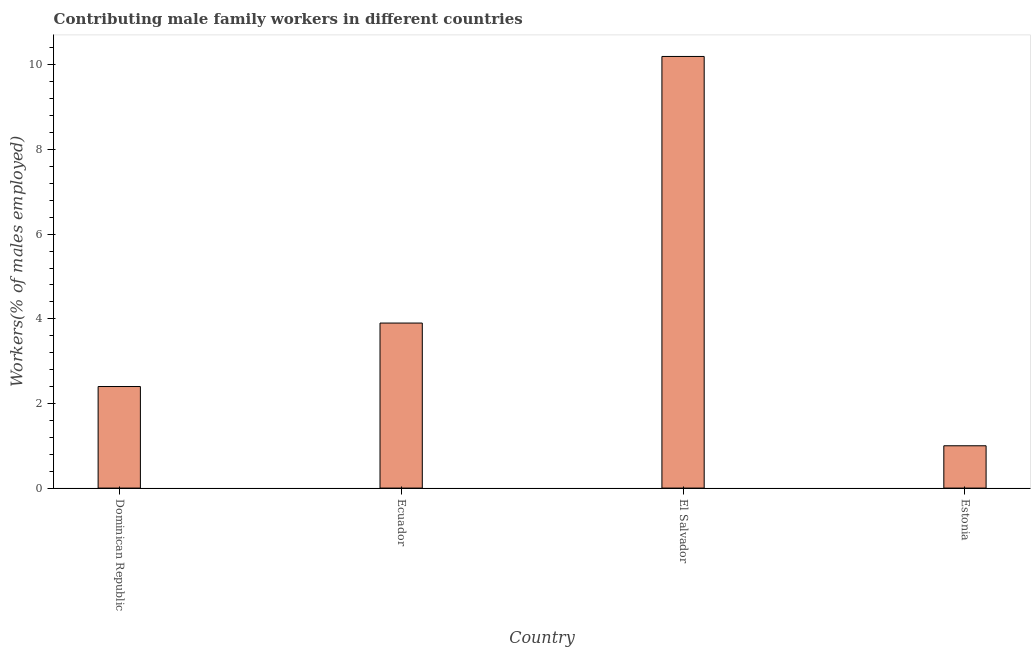What is the title of the graph?
Make the answer very short. Contributing male family workers in different countries. What is the label or title of the X-axis?
Offer a terse response. Country. What is the label or title of the Y-axis?
Give a very brief answer. Workers(% of males employed). What is the contributing male family workers in Dominican Republic?
Offer a terse response. 2.4. Across all countries, what is the maximum contributing male family workers?
Your response must be concise. 10.2. Across all countries, what is the minimum contributing male family workers?
Offer a terse response. 1. In which country was the contributing male family workers maximum?
Your answer should be compact. El Salvador. In which country was the contributing male family workers minimum?
Offer a very short reply. Estonia. What is the sum of the contributing male family workers?
Offer a very short reply. 17.5. What is the difference between the contributing male family workers in Ecuador and El Salvador?
Provide a short and direct response. -6.3. What is the average contributing male family workers per country?
Ensure brevity in your answer.  4.38. What is the median contributing male family workers?
Ensure brevity in your answer.  3.15. What is the ratio of the contributing male family workers in Dominican Republic to that in Estonia?
Ensure brevity in your answer.  2.4. Is the contributing male family workers in Ecuador less than that in El Salvador?
Provide a short and direct response. Yes. Is the difference between the contributing male family workers in El Salvador and Estonia greater than the difference between any two countries?
Make the answer very short. Yes. What is the difference between two consecutive major ticks on the Y-axis?
Ensure brevity in your answer.  2. Are the values on the major ticks of Y-axis written in scientific E-notation?
Ensure brevity in your answer.  No. What is the Workers(% of males employed) of Dominican Republic?
Offer a very short reply. 2.4. What is the Workers(% of males employed) in Ecuador?
Your response must be concise. 3.9. What is the Workers(% of males employed) in El Salvador?
Offer a very short reply. 10.2. What is the Workers(% of males employed) of Estonia?
Make the answer very short. 1. What is the difference between the Workers(% of males employed) in Dominican Republic and Ecuador?
Keep it short and to the point. -1.5. What is the difference between the Workers(% of males employed) in Dominican Republic and El Salvador?
Your answer should be very brief. -7.8. What is the difference between the Workers(% of males employed) in El Salvador and Estonia?
Your response must be concise. 9.2. What is the ratio of the Workers(% of males employed) in Dominican Republic to that in Ecuador?
Your answer should be compact. 0.61. What is the ratio of the Workers(% of males employed) in Dominican Republic to that in El Salvador?
Your answer should be compact. 0.23. What is the ratio of the Workers(% of males employed) in Dominican Republic to that in Estonia?
Provide a short and direct response. 2.4. What is the ratio of the Workers(% of males employed) in Ecuador to that in El Salvador?
Keep it short and to the point. 0.38. 